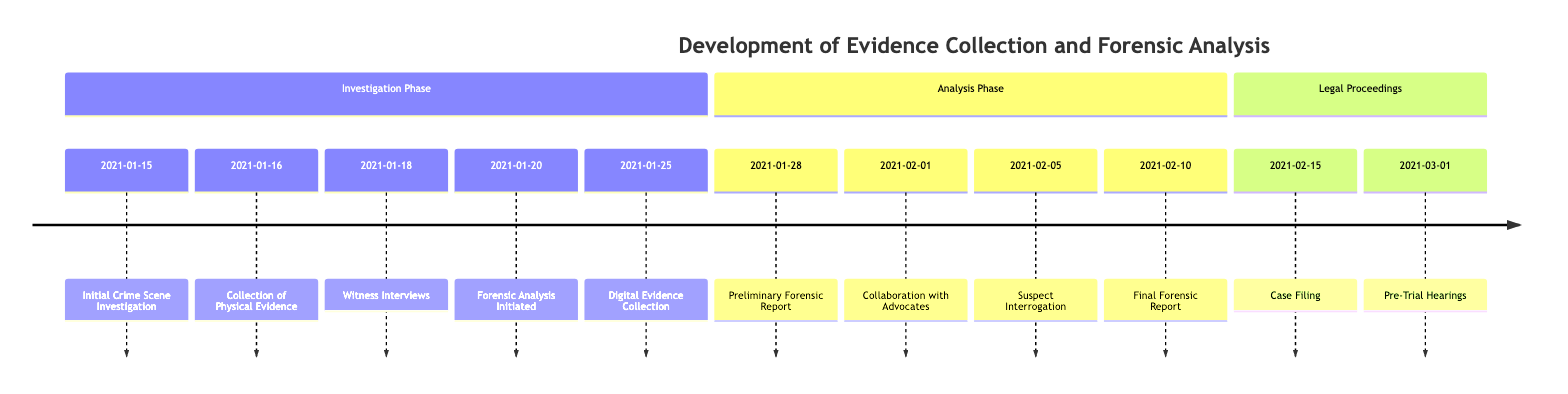What event occurred on January 15, 2021? The diagram indicates that on January 15, 2021, the event was "Initial Crime Scene Investigation." This is clearly stated in the timeline along with the date.
Answer: Initial Crime Scene Investigation How many phases are there in the timeline? The timeline is divided into three sections: Investigation Phase, Analysis Phase, and Legal Proceedings. Each of these phases groups related events together. Thus, there are three phases in total.
Answer: 3 Which event follows the witness interviews? According to the timeline, the event that follows "Witness Interviews" on January 18, 2021, is "Forensic Analysis Initiated," which occurs on January 20, 2021.
Answer: Forensic Analysis Initiated What was the last event before the case filing? The last event listed before "Case Filing" on February 15, 2021, is "Final Forensic Report," which takes place on February 10, 2021. This shows the chronological sequence leading up to the case being filed.
Answer: Final Forensic Report How many days passed between the collection of physical evidence and the preliminary forensic report? The collection of physical evidence occurred on January 16, 2021, and the preliminary forensic report was provided on January 28, 2021. Counting the days between these two events gives a total of 12 days.
Answer: 12 What events are included in the Analysis Phase? The Analysis Phase consists of four events: "Preliminary Forensic Report," "Collaboration with Advocates," "Suspect Interrogation," and "Final Forensic Report." These events are grouped in that specific section of the timeline.
Answer: Preliminary Forensic Report, Collaboration with Advocates, Suspect Interrogation, Final Forensic Report Which event mentions collaboration with advocates? The event that mentions "Collaboration with Advocates" is dated February 1, 2021. This event specifically indicates a meeting between police officers and advocates.
Answer: Collaboration with Advocates What step comes after digital evidence collection? Following "Digital Evidence Collection" on January 25, 2021, the next step indicated in the timeline is "Preliminary Forensic Report," which occurs on January 28, 2021. This shows the sequence of evidence analysis processes.
Answer: Preliminary Forensic Report When were pre-trial hearings conducted? According to the timeline, pre-trial hearings were conducted on March 1, 2021. This date is specifically marked as an event in the Legal Proceedings section.
Answer: March 1, 2021 